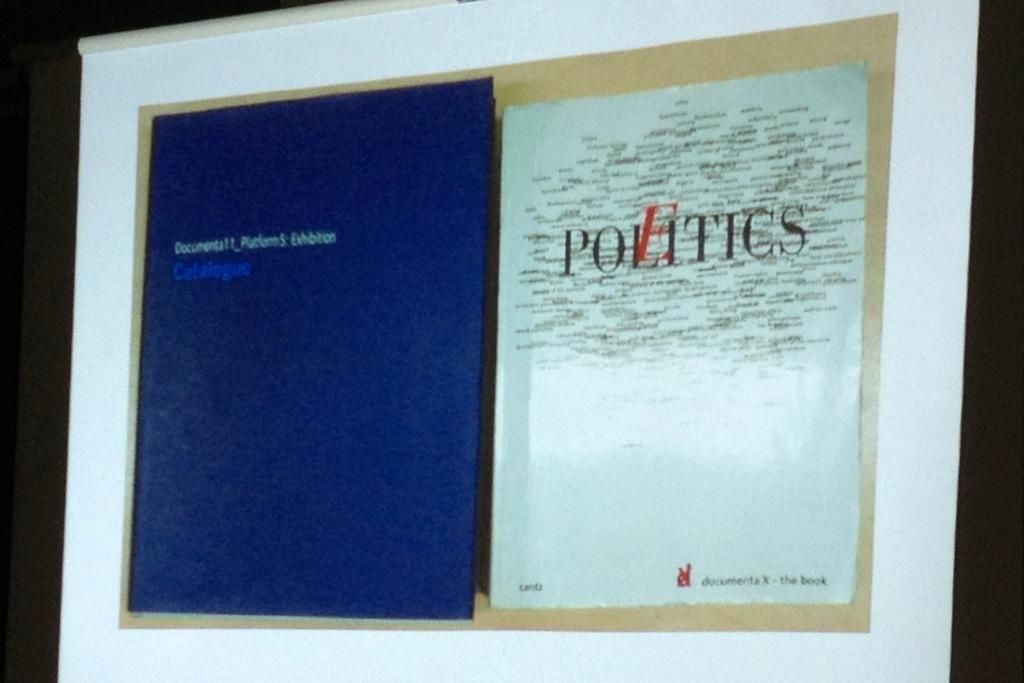<image>
Relay a brief, clear account of the picture shown. An open book that says politics on the right side. 